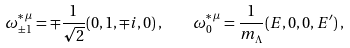Convert formula to latex. <formula><loc_0><loc_0><loc_500><loc_500>\omega ^ { * \, \mu } _ { \pm 1 } = \mp \frac { 1 } { \sqrt { 2 } } ( 0 , 1 , \mp i , 0 ) \, , \quad \omega ^ { * \, \mu } _ { 0 } = \frac { 1 } { m _ { \Lambda } } ( E , 0 , 0 , E ^ { \prime } ) \, ,</formula> 